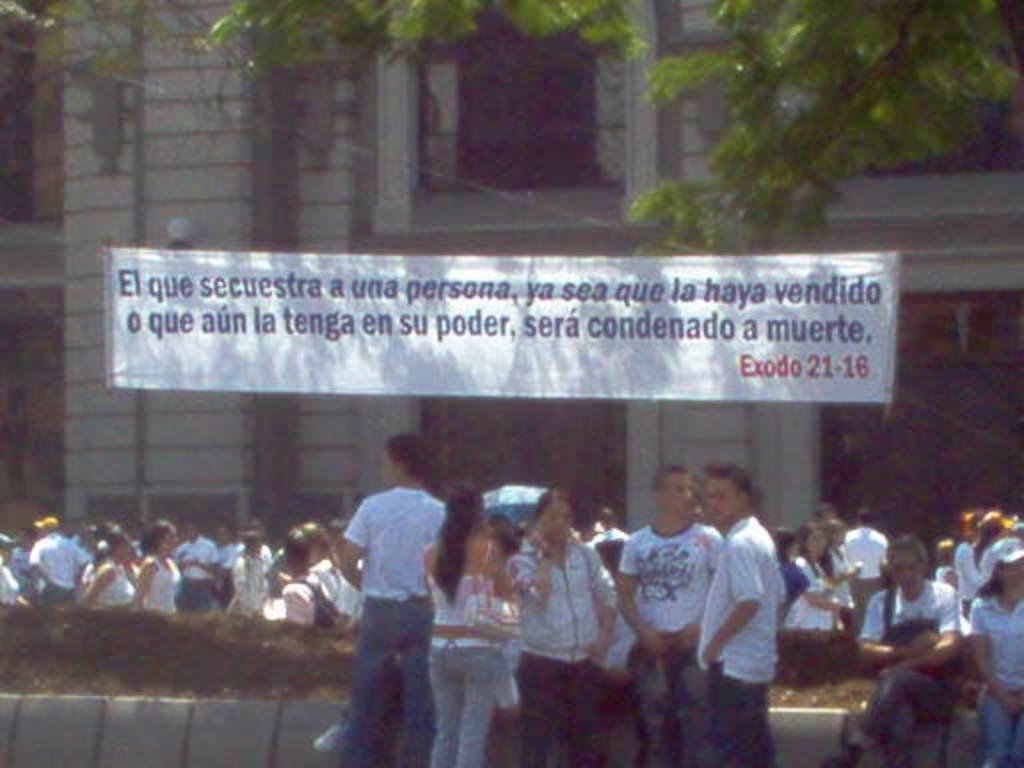How would you summarize this image in a sentence or two? In this image we can see people sitting on the wall and some are standing on the road. In the background we can see an advertisement hanged to the building and tree. 